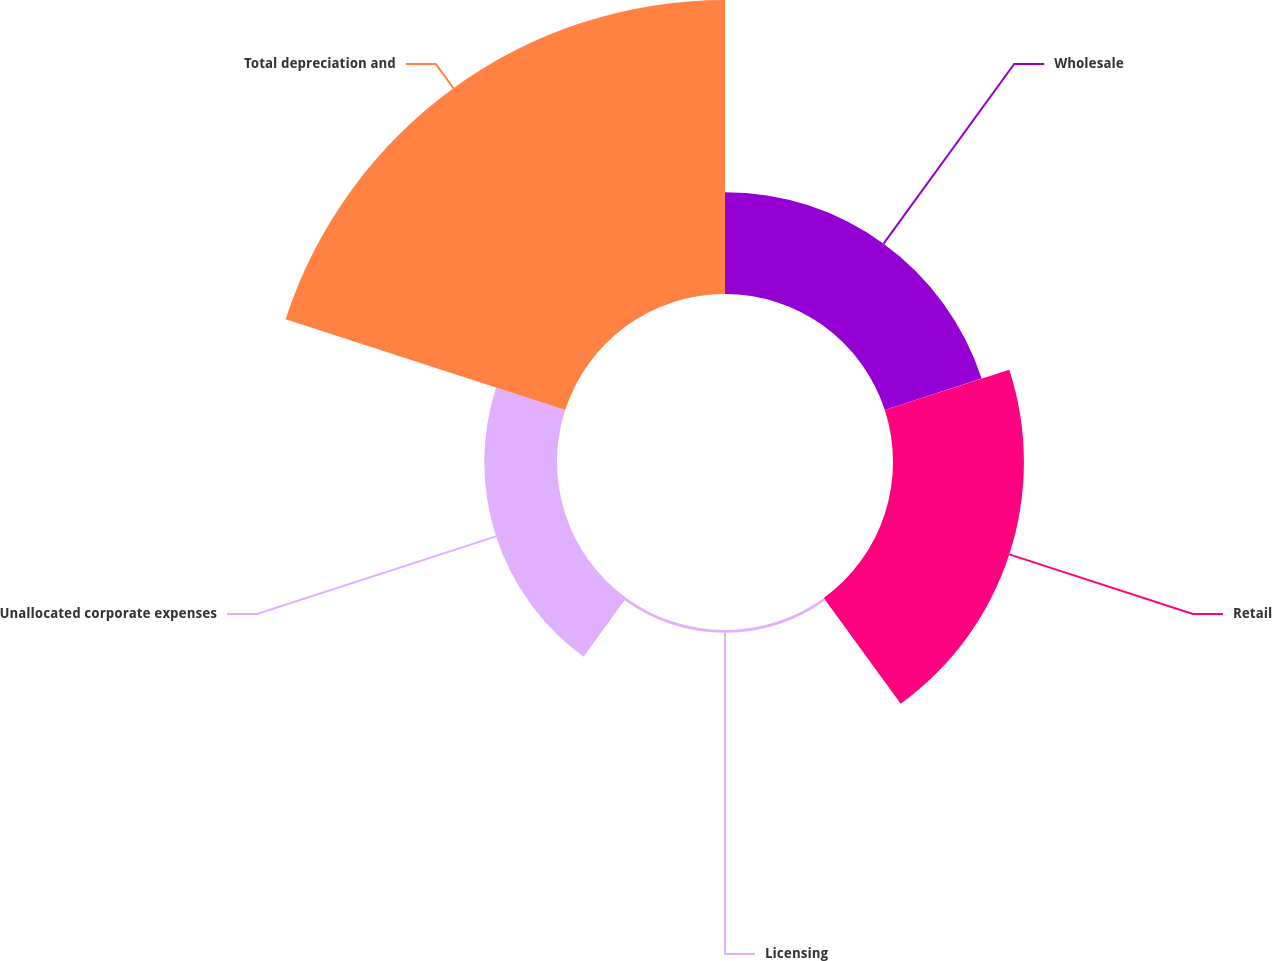<chart> <loc_0><loc_0><loc_500><loc_500><pie_chart><fcel>Wholesale<fcel>Retail<fcel>Licensing<fcel>Unallocated corporate expenses<fcel>Total depreciation and<nl><fcel>16.91%<fcel>21.74%<fcel>0.46%<fcel>12.07%<fcel>48.82%<nl></chart> 